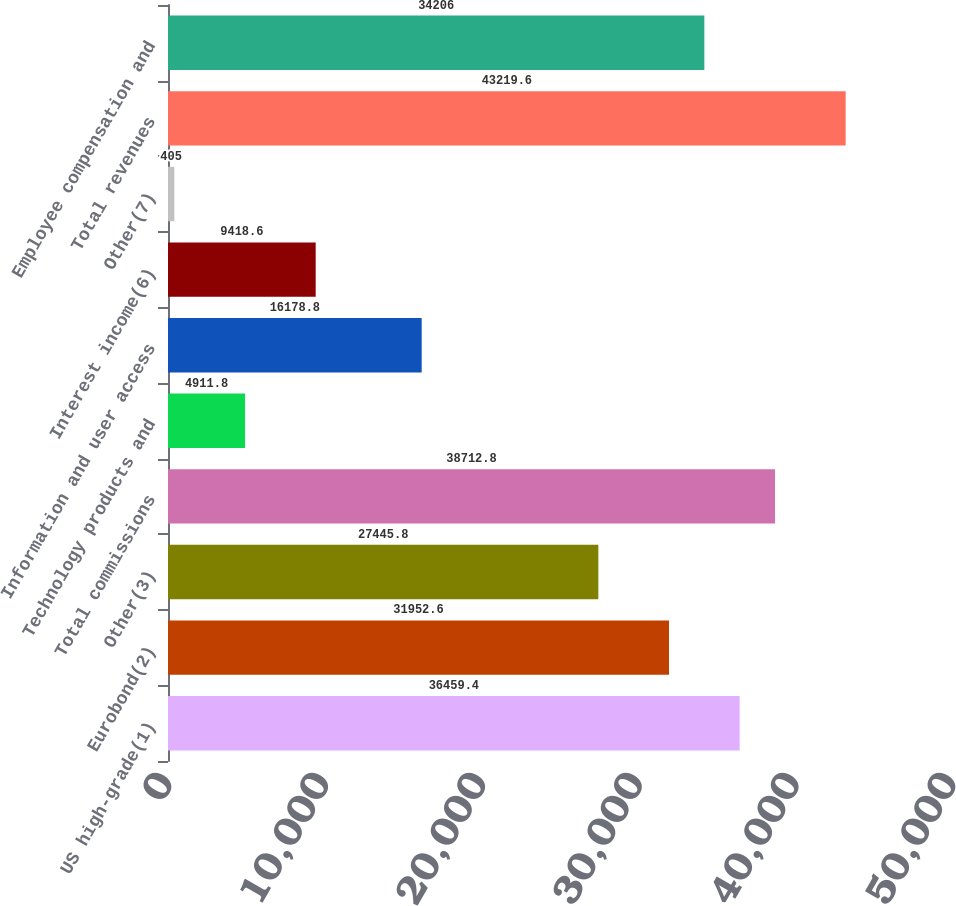<chart> <loc_0><loc_0><loc_500><loc_500><bar_chart><fcel>US high-grade(1)<fcel>Eurobond(2)<fcel>Other(3)<fcel>Total commissions<fcel>Technology products and<fcel>Information and user access<fcel>Interest income(6)<fcel>Other(7)<fcel>Total revenues<fcel>Employee compensation and<nl><fcel>36459.4<fcel>31952.6<fcel>27445.8<fcel>38712.8<fcel>4911.8<fcel>16178.8<fcel>9418.6<fcel>405<fcel>43219.6<fcel>34206<nl></chart> 